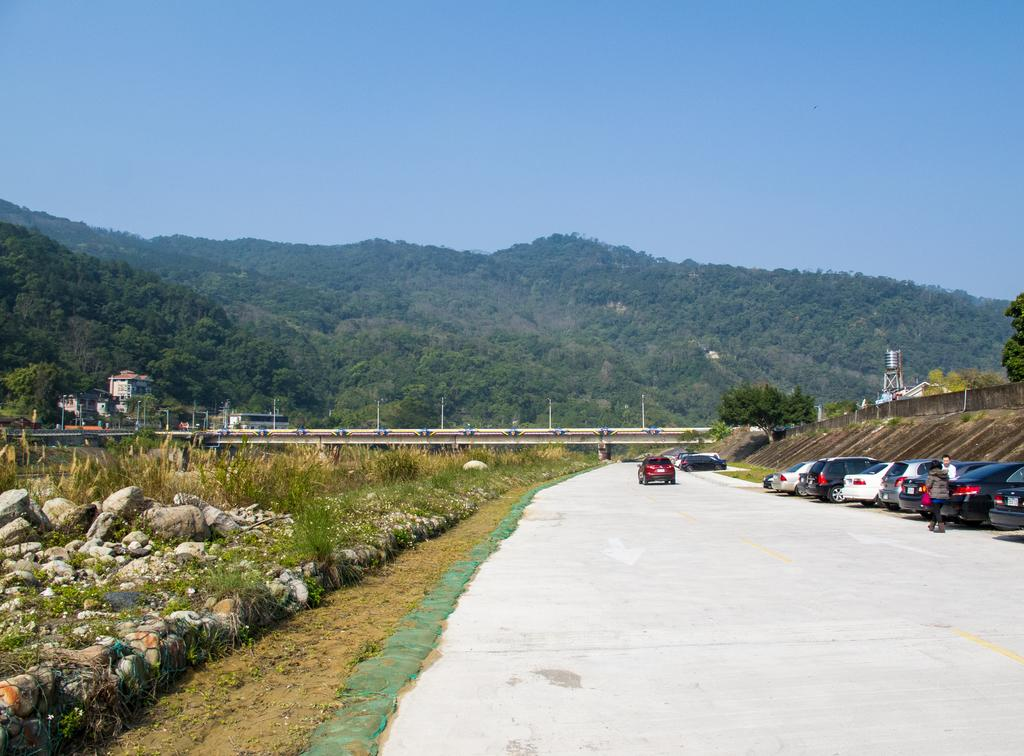What can be seen beside the road in the image? There are vehicles parked beside the road. What is happening on the road in the image? There are vehicles on the road. Are there any people visible in the image? Yes, there are people visible near the road. What type of natural elements can be seen near the road? Rocks and trees are present near the road. What type of man-made structures can be seen near the road? Buildings are present near the road. What can be seen in the background of the image? Hills are visible in the background. What type of wood is being produced by the trees near the road in the image? There is no indication of wood production in the image; the trees are simply present near the road. What type of trail can be seen near the road in the image? There is no trail visible in the image; only vehicles, people, rocks, trees, buildings, and hills are present. 